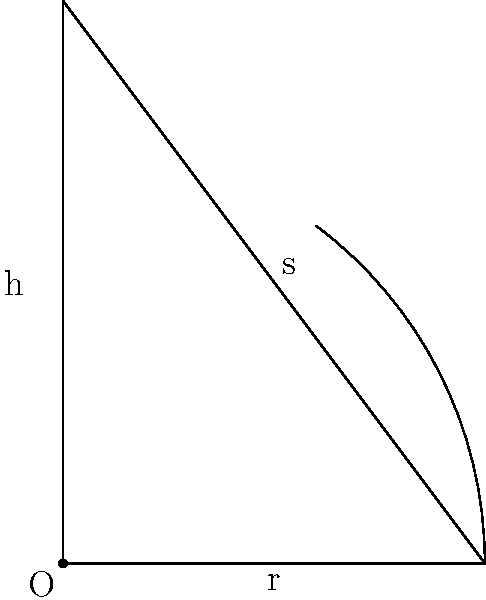As a LARPer preparing for a fantasy wizard role, you need to create a conical hat. The hat has a radius of 30 cm at the base and a slant height of 50 cm. Calculate the surface area of the hat, excluding the circular base, to determine how much fabric you'll need. Round your answer to the nearest square centimeter. To find the surface area of a conical wizard's hat (excluding the base), we need to calculate the lateral surface area of a cone. Let's break it down step-by-step:

1) The formula for the lateral surface area of a cone is:
   $$A = \pi rs$$
   where $r$ is the radius of the base and $s$ is the slant height.

2) We're given:
   $r = 30$ cm (radius of the base)
   $s = 50$ cm (slant height)

3) Let's substitute these values into our formula:
   $$A = \pi \cdot 30 \cdot 50$$

4) Simplify:
   $$A = 1500\pi$$

5) Calculate:
   $$A \approx 4712.39 \text{ cm}^2$$

6) Rounding to the nearest square centimeter:
   $$A \approx 4712 \text{ cm}^2$$

This is the amount of fabric you'll need to create the conical part of your wizard's hat for your LARP costume.
Answer: 4712 cm² 